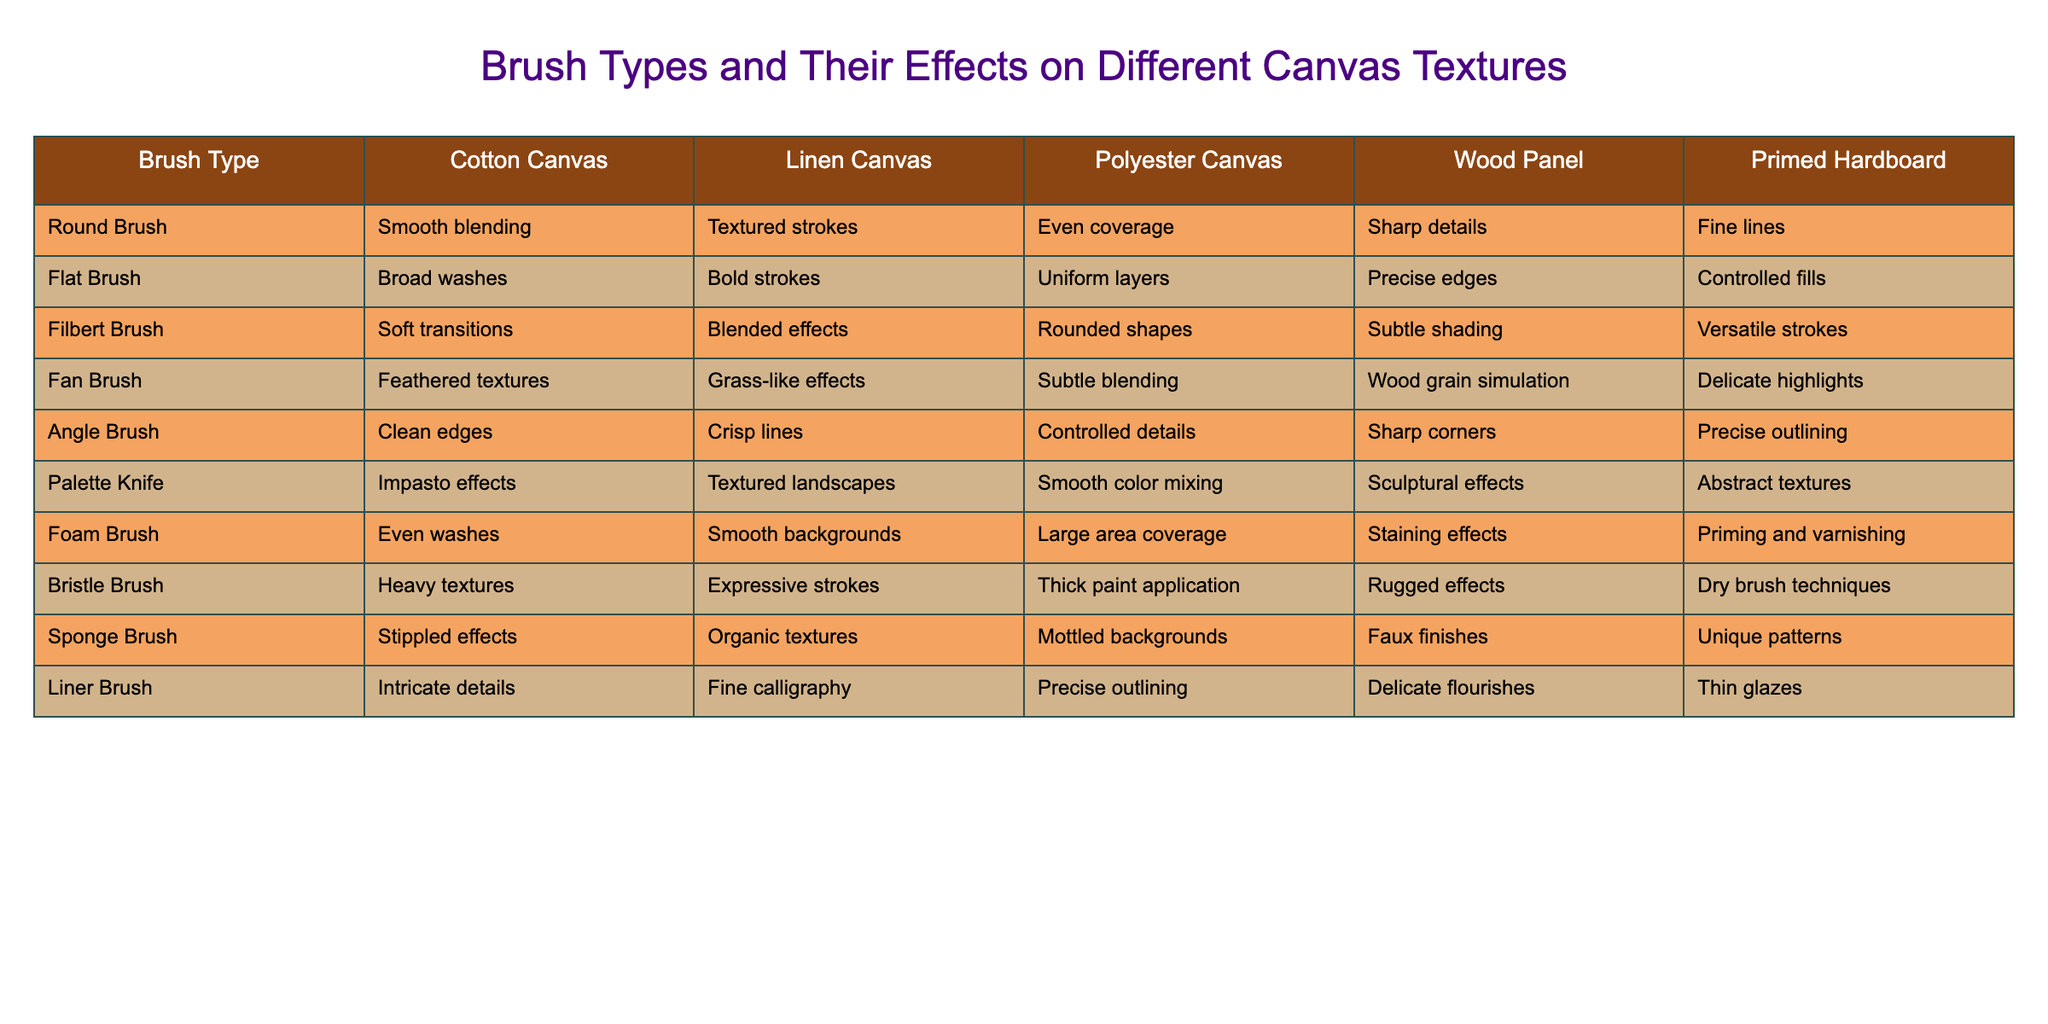What effect does a round brush have on cotton canvas? According to the table, a round brush provides smooth blending on cotton canvas.
Answer: Smooth blending Which brush type is best for achieving textured strokes on linen canvas? The table shows that a round brush is best for textured strokes on linen canvas.
Answer: Round Brush Does the palette knife create smooth color mixing on wood panels? The table indicates that the palette knife produces sculptural effects on wood panels, not smooth color mixing.
Answer: No What is the primary effect of a foam brush on polyester canvas? The table states that a foam brush provides large area coverage on polyester canvas.
Answer: Large area coverage Which brush type offers the finest details on primed hardboard? The table reveals that the liner brush is best for intricate details on primed hardboard.
Answer: Liner Brush How do the effects of the filbert brush compare to the angle brush on cotton canvas? The filbert brush offers soft transitions while the angle brush provides clean edges; hence, their effects differ in finishing style.
Answer: Differ in finishing style Which brush type provides broad washes on cotton canvas, and what are its effects on other surfaces? A flat brush offers broad washes on cotton canvas and delivers bold strokes on linen canvas, uniform layers on polyester canvas, precise edges on wood panels, and controlled fills on primed hardboard.
Answer: Flat Brush Which brush has the most versatile effects across different canvas types? The filbert brush shows versatility with different effects like soft transitions and rounded shapes across various canvases, indicating its adaptability.
Answer: Filbert Brush If you wanted to create faux finishes on wood panels, which brush would you use? The table indicates that a sponge brush creates faux finishes on wood panels.
Answer: Sponge Brush How would you describe the effect of a bristle brush on linen canvas compared to a fan brush? The bristle brush creates heavy textures while the fan brush produces feathered textures; thus, they offer contrasting effects on linen canvas.
Answer: Contrasting effects 